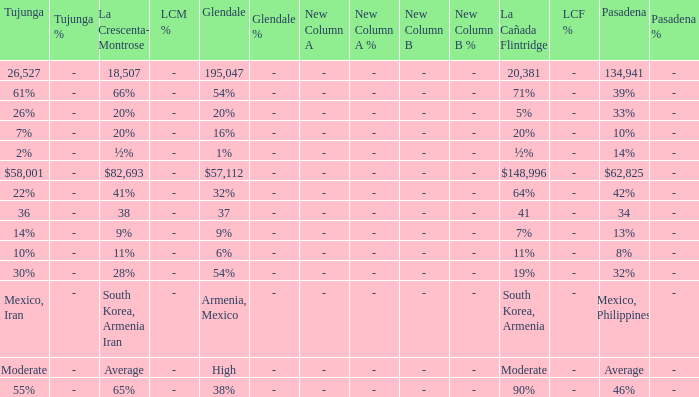What is the percentage of Tujunja when Pasadena is 33%? 26%. 